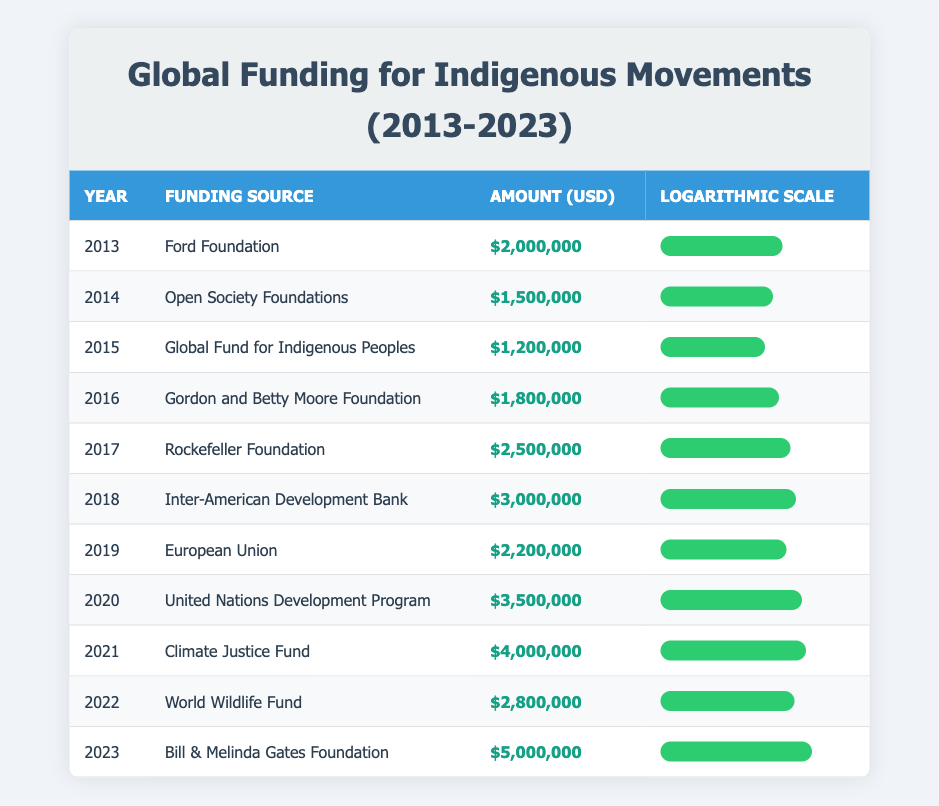What was the funding amount from the Climate Justice Fund in 2021? The table clearly shows that the funding from the Climate Justice Fund in 2021 was $4,000,000.
Answer: $4,000,000 Which funding source provided the highest amount over the last decade? By inspecting the amounts in the table, the Bill & Melinda Gates Foundation provided the highest amount of $5,000,000 in 2023.
Answer: Bill & Melinda Gates Foundation What is the total funding amount over the last decade? To find the total, we add up all the amounts: $2,000,000 + $1,500,000 + $1,200,000 + $1,800,000 + $2,500,000 + $3,000,000 + $2,200,000 + $3,500,000 + $4,000,000 + $2,800,000 + $5,000,000 = $27,500,000.
Answer: $27,500,000 Did the funding from the Open Society Foundations increase from the previous year? Comparing the funding amounts, in 2014 the Open Society Foundations provided $1,500,000, which was less than the previous year’s Ford Foundation funding of $2,000,000, so the answer is no.
Answer: No What was the year with the second highest funding, and what was the amount? By reviewing the table, we see that the second highest funding was in 2021 with $4,000,000 from the Climate Justice Fund, after 2023, which had $5,000,000.
Answer: 2021, $4,000,000 How much more did the United Nations Development Program fund compared to the Global Fund for Indigenous Peoples? The United Nations Development Program funded $3,500,000 while the Global Fund for Indigenous Peoples provided $1,200,000. The difference is $3,500,000 - $1,200,000 = $2,300,000.
Answer: $2,300,000 What percentage of the total funding in 2023 did the Bill & Melinda Gates Foundation contribute? First calculate the total funding ($27,500,000) and then the contribution: (5,000,000 / 27,500,000) * 100 = 18.18%. The Bill & Melinda Gates Foundation contributed 18.18% of the total funding.
Answer: 18.18% Was the funding amount in 2020 higher than the funding amount in 2017? The funding for 2020 was $3,500,000 while in 2017 it was $2,500,000. Thus $3,500,000 is greater than $2,500,000, making the statement true.
Answer: Yes 